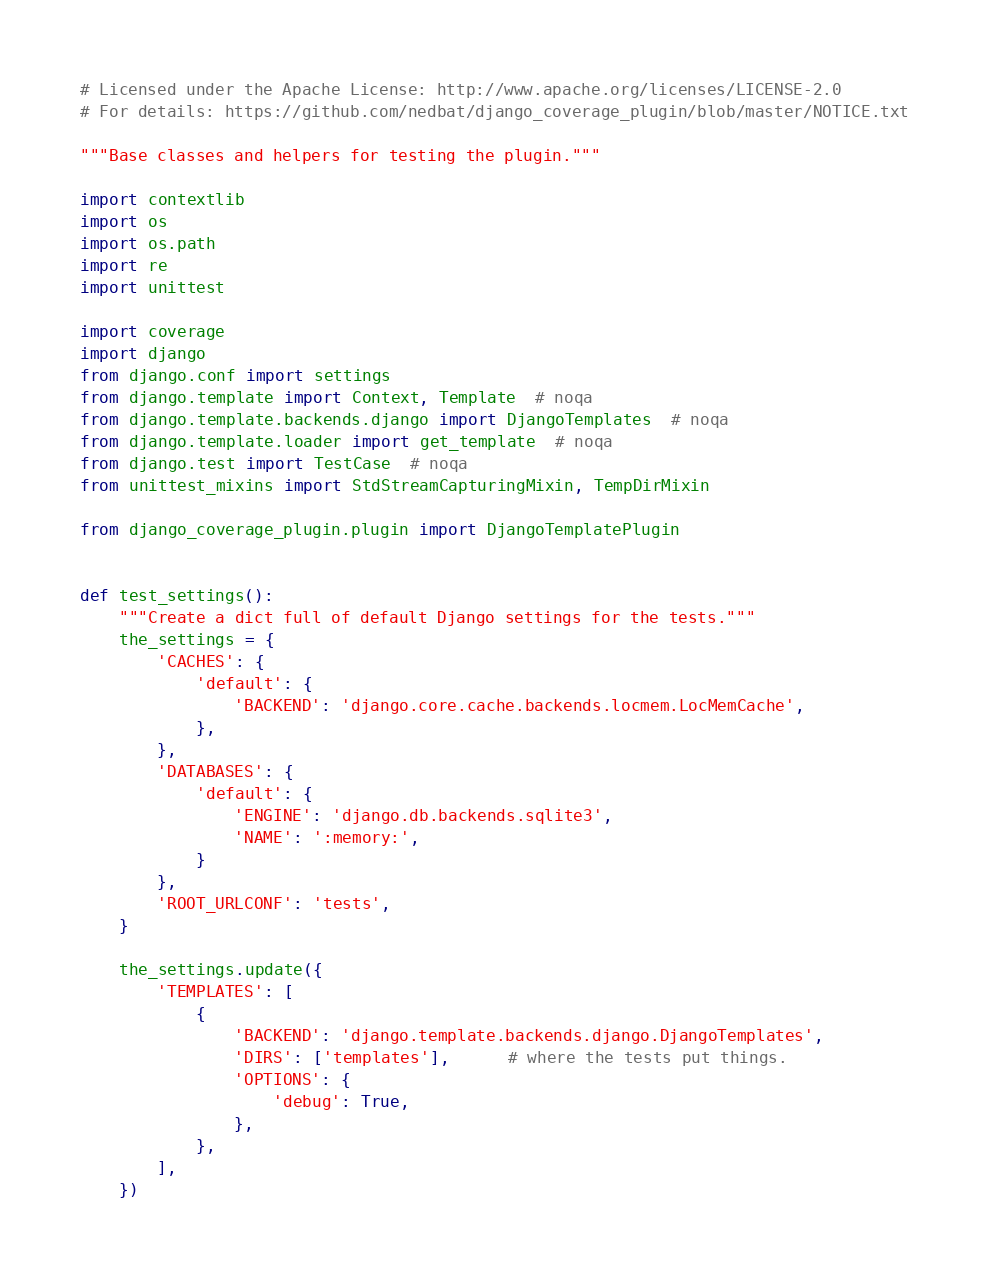<code> <loc_0><loc_0><loc_500><loc_500><_Python_># Licensed under the Apache License: http://www.apache.org/licenses/LICENSE-2.0
# For details: https://github.com/nedbat/django_coverage_plugin/blob/master/NOTICE.txt

"""Base classes and helpers for testing the plugin."""

import contextlib
import os
import os.path
import re
import unittest

import coverage
import django
from django.conf import settings
from django.template import Context, Template  # noqa
from django.template.backends.django import DjangoTemplates  # noqa
from django.template.loader import get_template  # noqa
from django.test import TestCase  # noqa
from unittest_mixins import StdStreamCapturingMixin, TempDirMixin

from django_coverage_plugin.plugin import DjangoTemplatePlugin


def test_settings():
    """Create a dict full of default Django settings for the tests."""
    the_settings = {
        'CACHES': {
            'default': {
                'BACKEND': 'django.core.cache.backends.locmem.LocMemCache',
            },
        },
        'DATABASES': {
            'default': {
                'ENGINE': 'django.db.backends.sqlite3',
                'NAME': ':memory:',
            }
        },
        'ROOT_URLCONF': 'tests',
    }

    the_settings.update({
        'TEMPLATES': [
            {
                'BACKEND': 'django.template.backends.django.DjangoTemplates',
                'DIRS': ['templates'],      # where the tests put things.
                'OPTIONS': {
                    'debug': True,
                },
            },
        ],
    })
</code> 